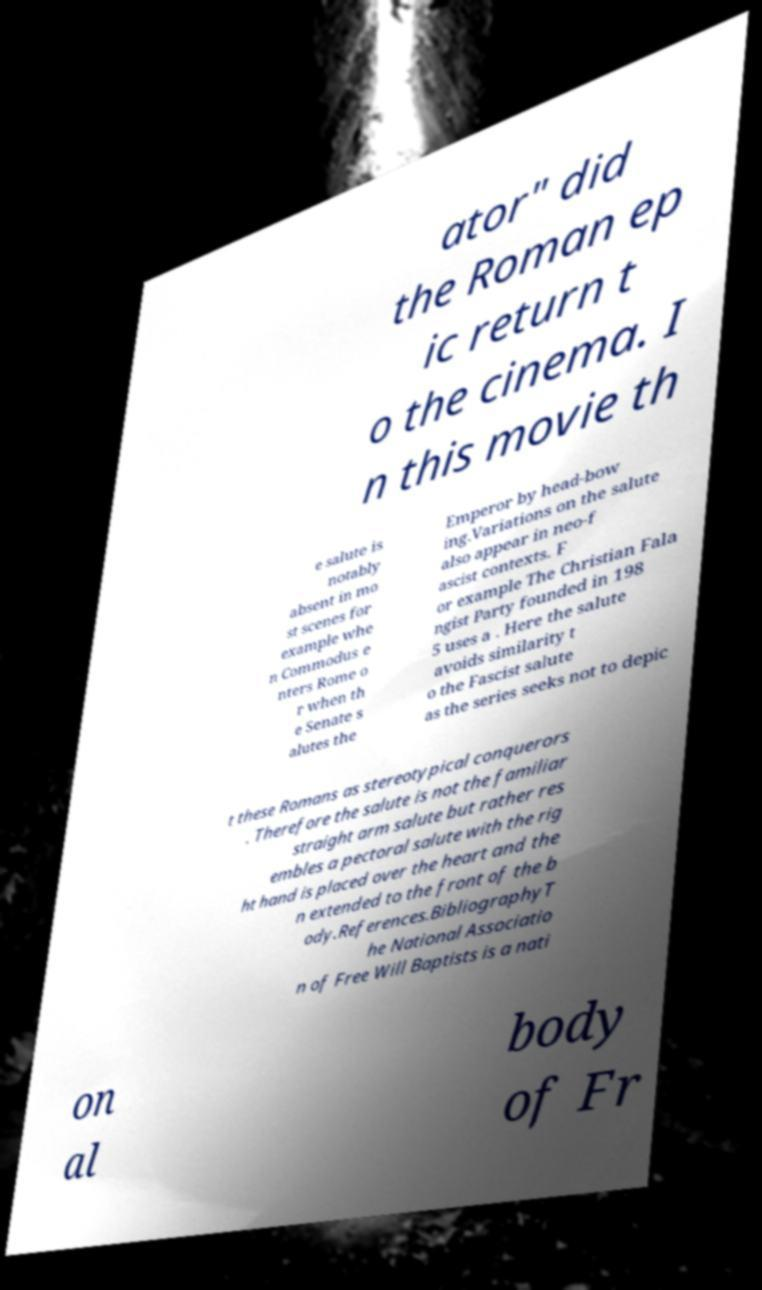Could you assist in decoding the text presented in this image and type it out clearly? ator" did the Roman ep ic return t o the cinema. I n this movie th e salute is notably absent in mo st scenes for example whe n Commodus e nters Rome o r when th e Senate s alutes the Emperor by head-bow ing.Variations on the salute also appear in neo-f ascist contexts. F or example The Christian Fala ngist Party founded in 198 5 uses a . Here the salute avoids similarity t o the Fascist salute as the series seeks not to depic t these Romans as stereotypical conquerors . Therefore the salute is not the familiar straight arm salute but rather res embles a pectoral salute with the rig ht hand is placed over the heart and the n extended to the front of the b ody.References.BibliographyT he National Associatio n of Free Will Baptists is a nati on al body of Fr 